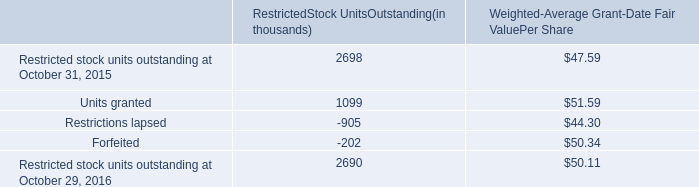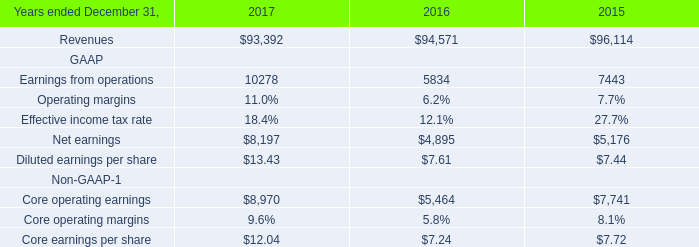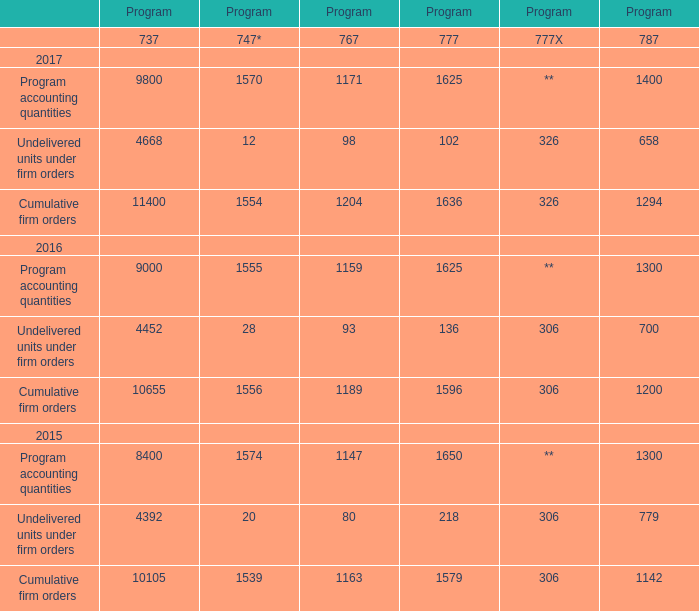what is the percentage change in the total grant-date fair value of shares vested in 2016 compare to 2015? 
Computations: ((62.8 - 65.6) / 65.6)
Answer: -0.04268. 